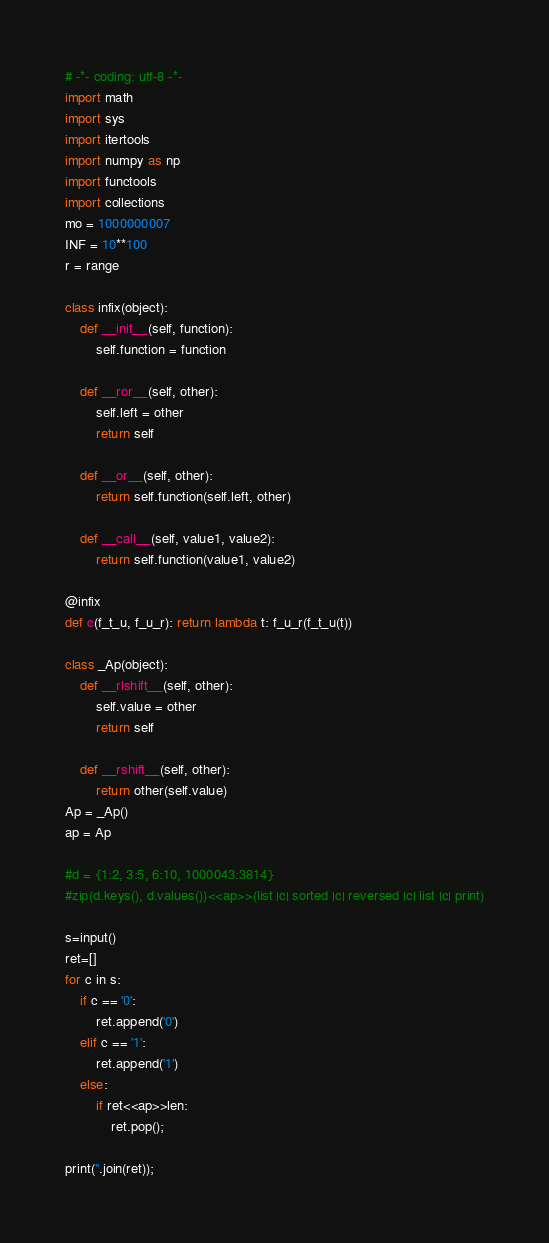Convert code to text. <code><loc_0><loc_0><loc_500><loc_500><_Python_># -*- coding: utf-8 -*-
import math
import sys
import itertools
import numpy as np
import functools
import collections
mo = 1000000007
INF = 10**100
r = range

class infix(object):
    def __init__(self, function):
        self.function = function

    def __ror__(self, other):
        self.left = other
        return self

    def __or__(self, other):
        return self.function(self.left, other)

    def __call__(self, value1, value2):
        return self.function(value1, value2)

@infix
def c(f_t_u, f_u_r): return lambda t: f_u_r(f_t_u(t))

class _Ap(object):
    def __rlshift__(self, other):
        self.value = other
        return self

    def __rshift__(self, other):
        return other(self.value)
Ap = _Ap()
ap = Ap

#d = {1:2, 3:5, 6:10, 1000043:3814}
#zip(d.keys(), d.values())<<ap>>(list |c| sorted |c| reversed |c| list |c| print)

s=input()
ret=[]
for c in s:
    if c == '0':
        ret.append('0')
    elif c == '1':
        ret.append('1')
    else:
        if ret<<ap>>len:
            ret.pop();

print(''.join(ret));
</code> 